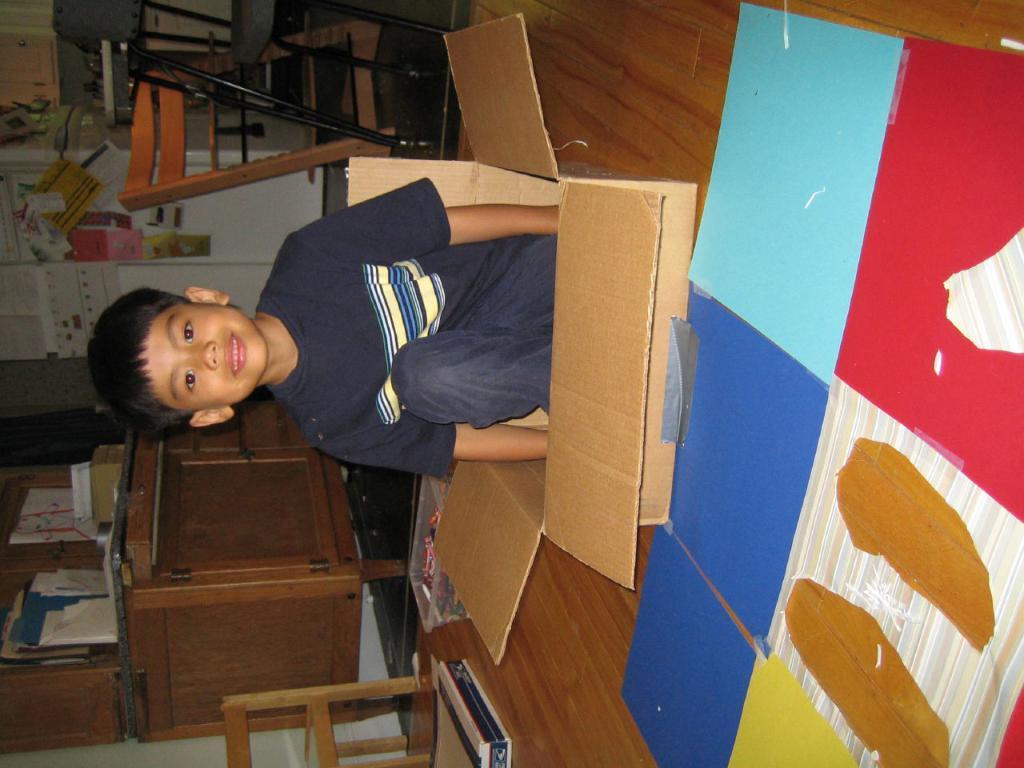Can you describe this image briefly? In the image we can see a boy sitting in the box. 